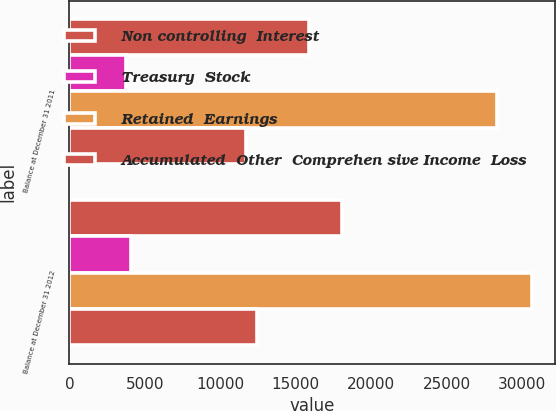Convert chart to OTSL. <chart><loc_0><loc_0><loc_500><loc_500><stacked_bar_chart><ecel><fcel>Balance at December 31 2011<fcel>Balance at December 31 2012<nl><fcel>Non controlling  Interest<fcel>15862<fcel>18040<nl><fcel>Treasury  Stock<fcel>3776<fcel>4053<nl><fcel>Retained  Earnings<fcel>28348<fcel>30679<nl><fcel>Accumulated  Other  Comprehen sive Income  Loss<fcel>11679<fcel>12407<nl></chart> 